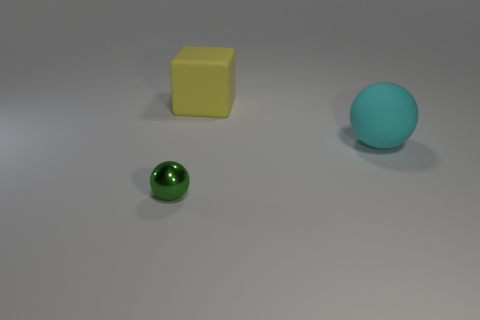Add 1 cyan matte balls. How many objects exist? 4 Subtract all blocks. How many objects are left? 2 Subtract 0 blue cylinders. How many objects are left? 3 Subtract all cyan balls. Subtract all cyan matte spheres. How many objects are left? 1 Add 1 big cyan matte objects. How many big cyan matte objects are left? 2 Add 3 tiny green things. How many tiny green things exist? 4 